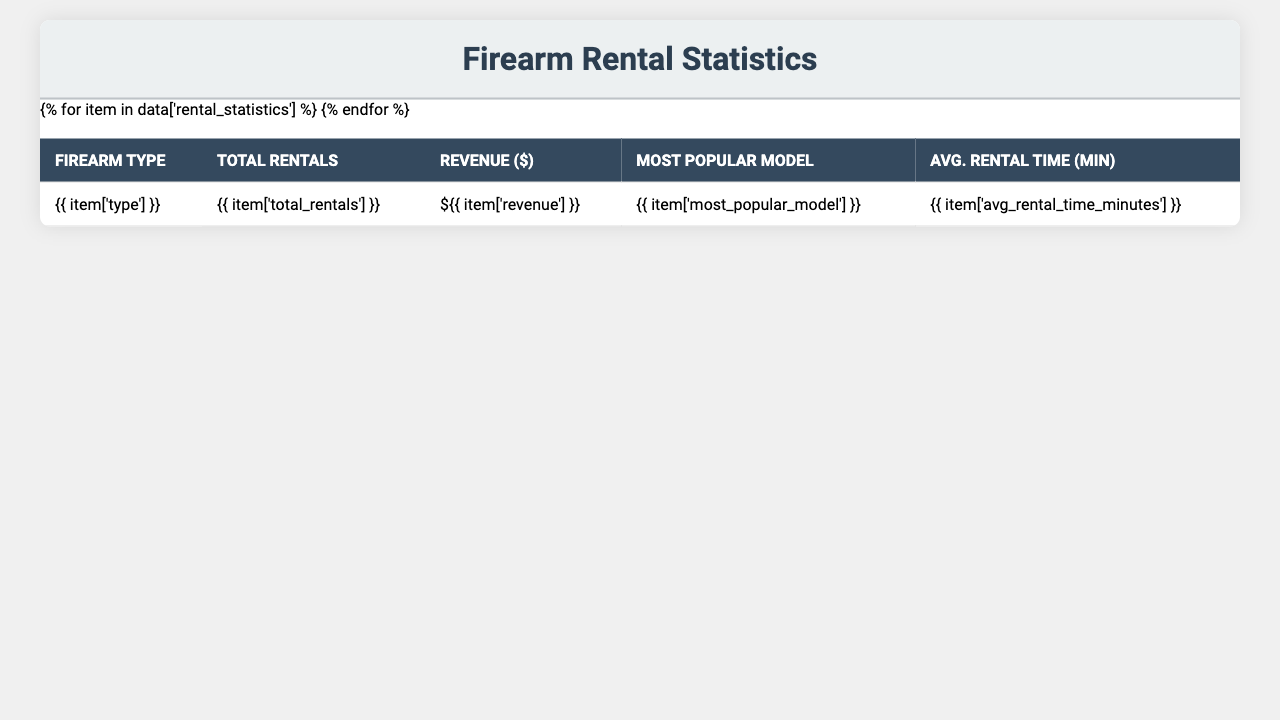What's the total revenue generated from handgun rentals? The total revenue for handgun rentals is listed under the revenue column for handguns, which is $48,675.
Answer: $48,675 Which firearm type had the highest total rentals? Looking at the total rentals column, handguns have the highest count with 3,245 rentals, compared to other types.
Answer: Handguns What was the average rental time for semi-automatic pistols? The average rental time for semi-automatic pistols can be found in the average rental time column, which is 50 minutes.
Answer: 50 minutes How much revenue did rifles generate compared to revolvers? Rifles generated $37,520 while revolvers generated $16,545. The difference in revenue is $37,520 - $16,545 = $20,975, indicating rifles made significantly more.
Answer: $20,975 more What percentage of total rentals were shotguns? The total rentals for shotguns is 982. The overall total rentals is the sum of all rentals: 3,245 + 1,876 + 982 + 2,789 + 1,103 = 11,995. The percentage is (982 / 11,995) * 100 ≈ 8.2%.
Answer: 8.2% Which firearm type is the most popular based on the average rental time? Comparing the average rental times, rifles have the highest at 60 minutes, followed by semi-automatic pistols at 50 minutes. Therefore, rifles are the most popular based on average rental time.
Answer: Rifles Was there a month where rentals exceeded 1,400? By checking the monthly data, we see that the months of July and August both had total rentals exceeding 1,400 (1,378 and 1,421 respectively).
Answer: Yes What was the total revenue from training courses? To find the total revenue from training courses, we add the revenues: $22,800 (Basic Firearm Safety) + $31,200 (Concealed Carry Certification) + $26,700 (Advanced Marksmanship) = $80,700.
Answer: $80,700 What is the total number of rentals for the entire year? The total rentals for the entire year can be calculated by summing all monthly rentals: 823 + 756 + 912 + 1045 + 1132 + 1256 + 1378 + 1421 + 1289 + 1156 + 987 + 840 = 13,560.
Answer: 13,560 Is the most popular model for shotguns the same as for revolvers? The most popular model for shotguns is the "Mossberg 500" while for revolvers it's the "Smith & Wesson Model 642". Since they are different, the answer is no.
Answer: No What age group has the highest percentage among customers? The age group with the highest percentage is 31-40, which accounts for 35% of the customers.
Answer: 31-40 age group 